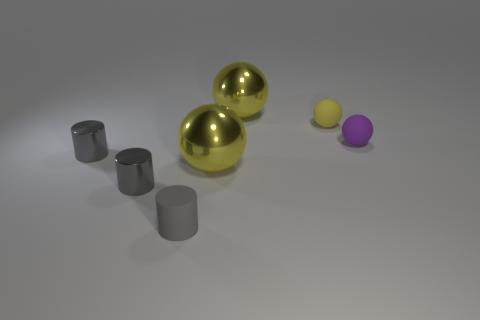Subtract all brown cylinders. How many yellow spheres are left? 3 Subtract 1 balls. How many balls are left? 3 Add 2 large yellow shiny spheres. How many objects exist? 9 Subtract all spheres. How many objects are left? 3 Add 1 purple balls. How many purple balls exist? 2 Subtract 0 cyan cubes. How many objects are left? 7 Subtract all small gray rubber things. Subtract all purple objects. How many objects are left? 5 Add 7 tiny gray shiny cylinders. How many tiny gray shiny cylinders are left? 9 